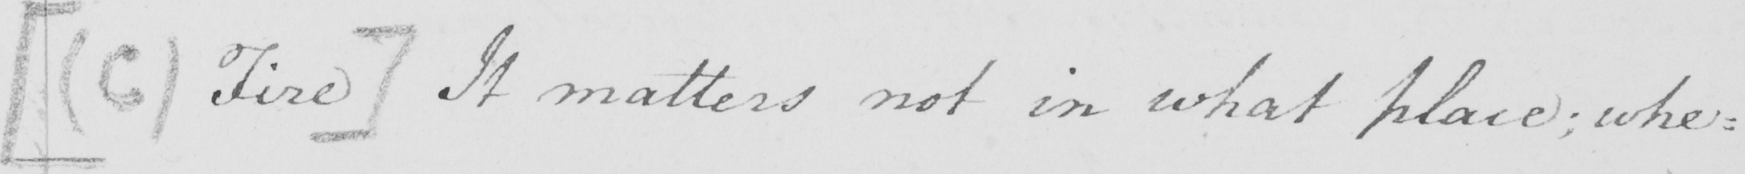Transcribe the text shown in this historical manuscript line. [  ( C ) Fire ]  It matters not in what place ; whe : 